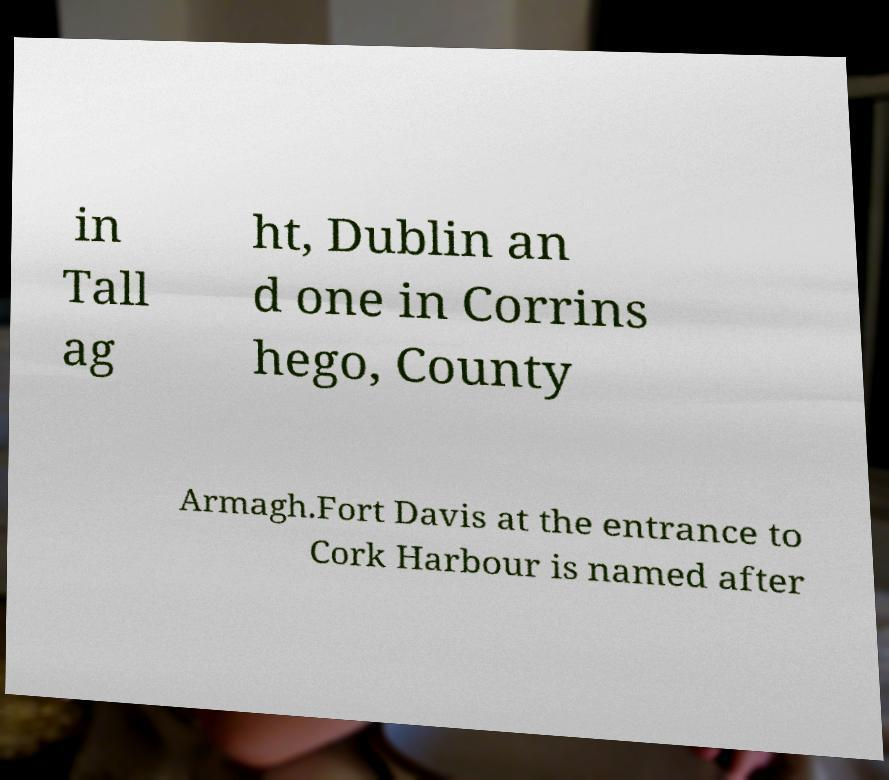Could you assist in decoding the text presented in this image and type it out clearly? in Tall ag ht, Dublin an d one in Corrins hego, County Armagh.Fort Davis at the entrance to Cork Harbour is named after 